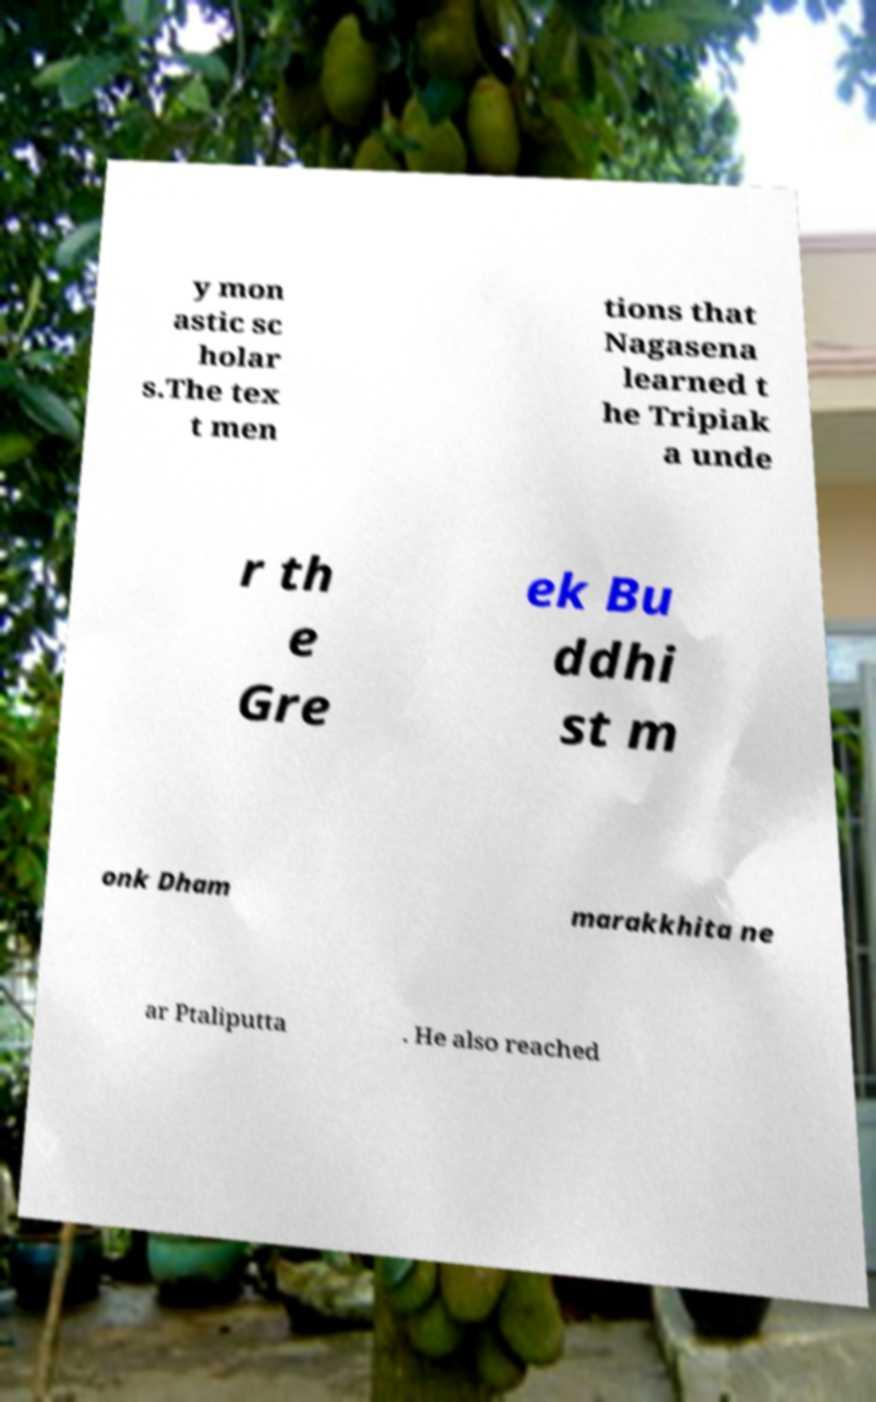There's text embedded in this image that I need extracted. Can you transcribe it verbatim? y mon astic sc holar s.The tex t men tions that Nagasena learned t he Tripiak a unde r th e Gre ek Bu ddhi st m onk Dham marakkhita ne ar Ptaliputta . He also reached 